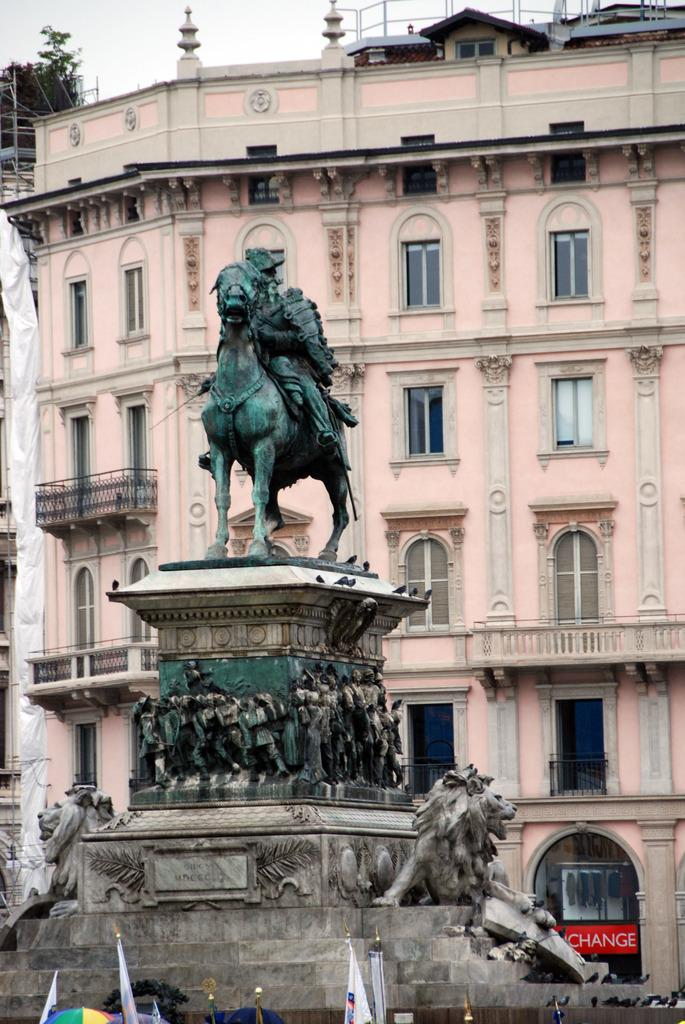<image>
Give a short and clear explanation of the subsequent image. A statue of a man on a horse sits atop a pedestal in front of a machine that says Change in the background. 